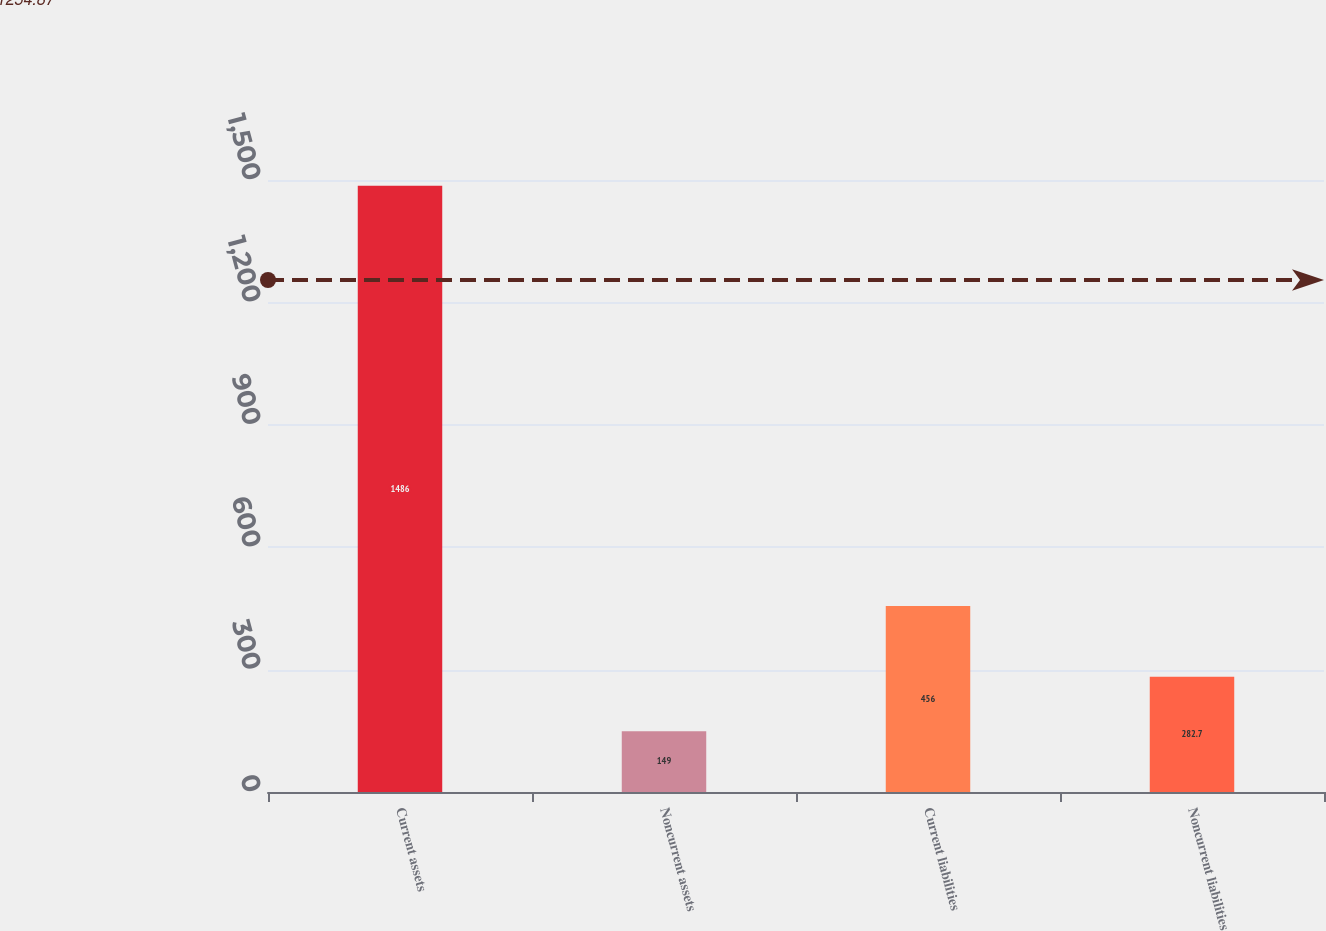Convert chart. <chart><loc_0><loc_0><loc_500><loc_500><bar_chart><fcel>Current assets<fcel>Noncurrent assets<fcel>Current liabilities<fcel>Noncurrent liabilities<nl><fcel>1486<fcel>149<fcel>456<fcel>282.7<nl></chart> 